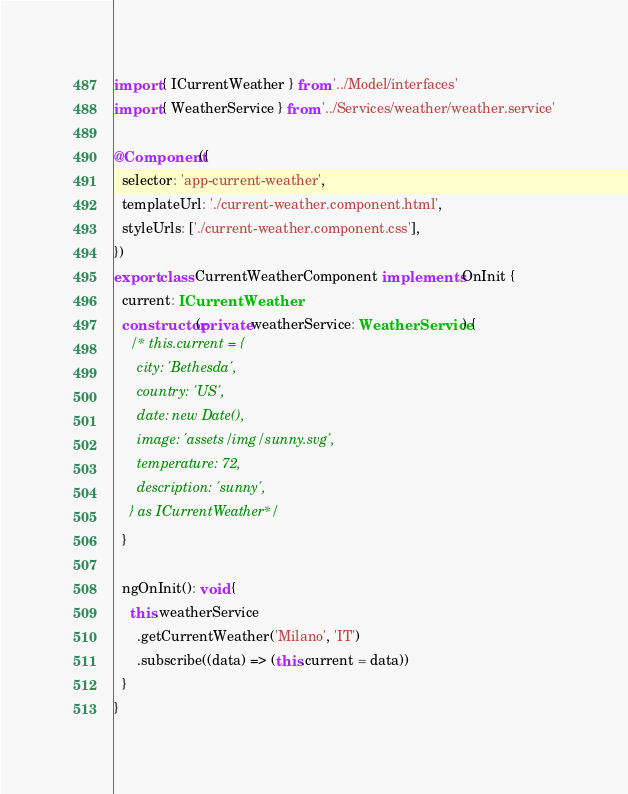Convert code to text. <code><loc_0><loc_0><loc_500><loc_500><_TypeScript_>
import { ICurrentWeather } from '../Model/interfaces'
import { WeatherService } from '../Services/weather/weather.service'

@Component({
  selector: 'app-current-weather',
  templateUrl: './current-weather.component.html',
  styleUrls: ['./current-weather.component.css'],
})
export class CurrentWeatherComponent implements OnInit {
  current: ICurrentWeather
  constructor(private weatherService: WeatherService) {
    /* this.current = {
      city: 'Bethesda',
      country: 'US',
      date: new Date(),
      image: 'assets/img/sunny.svg',
      temperature: 72,
      description: 'sunny',
    } as ICurrentWeather*/
  }

  ngOnInit(): void {
    this.weatherService
      .getCurrentWeather('Milano', 'IT')
      .subscribe((data) => (this.current = data))
  }
}
</code> 